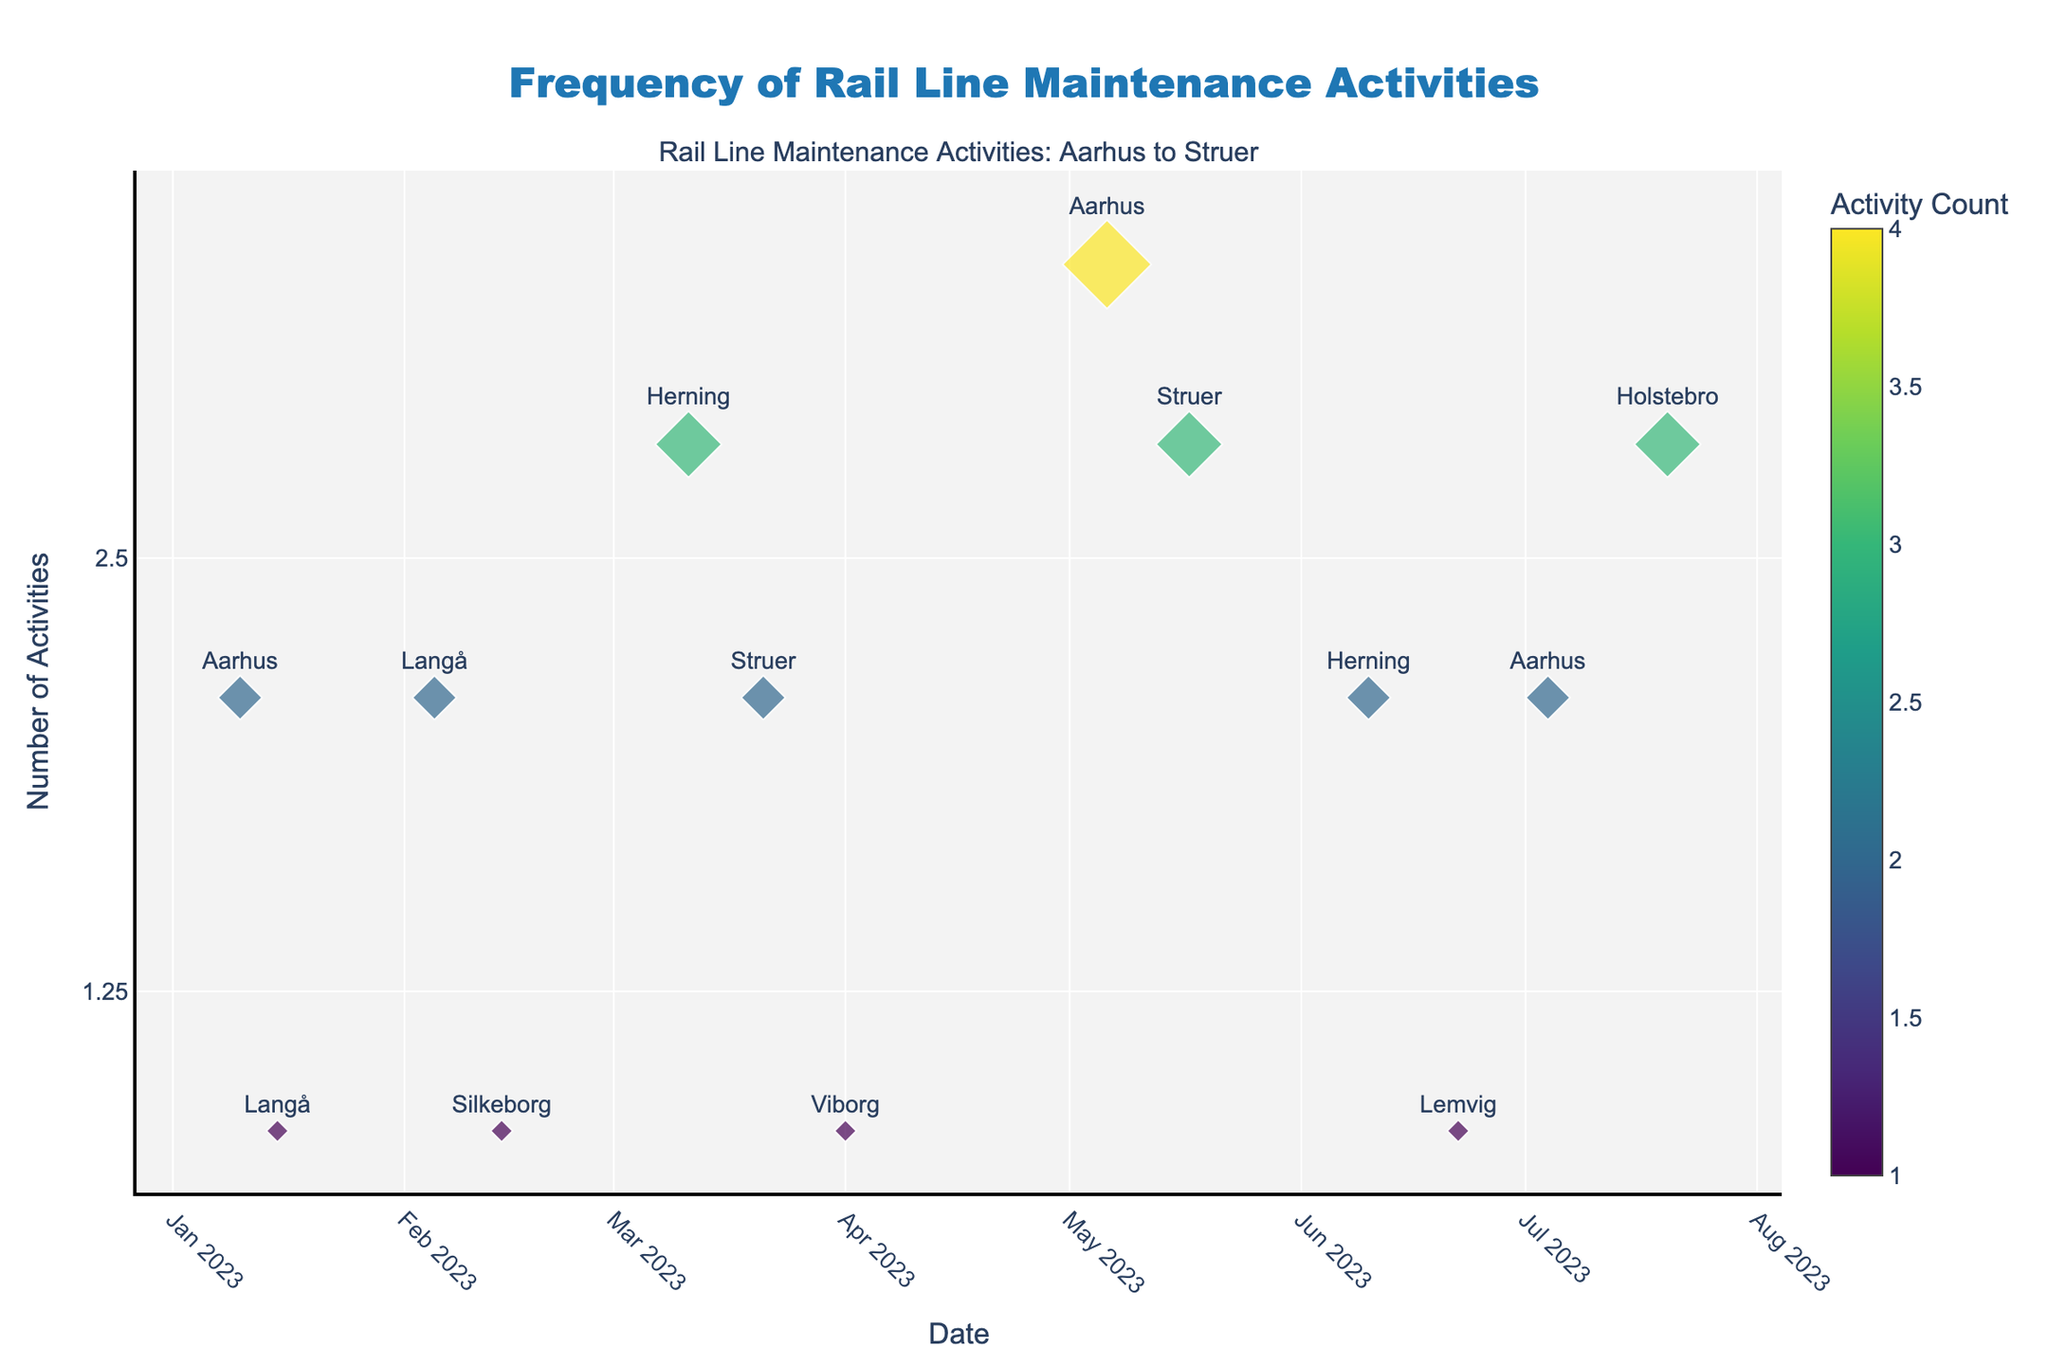What is the title of the plot? The title is usually found at the top of the plot. In this case, it reads "Frequency of Rail Line Maintenance Activities".
Answer: Frequency of Rail Line Maintenance Activities How many maintenance activities were recorded in Aarhus in May? Locate the markers labeled "Aarhus" on the plot. There is a point in May, and the Activity Count indicated is 4.
Answer: 4 Which location had the highest number of maintenance activities and how many were there? Look for the largest marker on the plot. The largest marker appears in May for Aarhus with an Activity Count of 4.
Answer: Aarhus, 4 How does the log scale on the y-axis affect the representation of Activity Counts? The log scale compresses the range of high values and expands the range of low values, making it easier to compare Activity Counts that vary widely. For example, the difference between 1 and 2 is shown more prominently, while higher values like 2, 3, and 4 appear closer together.
Answer: Compresses high values, expands low values What is the total number of maintenance activities recorded in Struer over the given period? Identify the markers labeled "Struer" and sum their Activity Counts: 2 (March) + 3 (May) = 5.
Answer: 5 Which date had a maintenance activity count of 3 in Herning? Find the marker corresponding to Herning with an Activity Count of 3. This is seen in March.
Answer: March 11, 2023 What are the distinct locations where maintenance activities were recorded? Look at the text labels on the plot for the different locations. The locations include Aarhus, Langå, Silkeborg, Herning, Struer, Viborg, Lemvig, and Holstebro.
Answer: Aarhus, Langå, Silkeborg, Herning, Struer, Viborg, Lemvig, Holstebro Compare the maintenance activities in March and June in Herning. Which month had more activities? Locate the markers for Herning in March and June. March has an Activity Count of 3, and June has 2. Therefore, March had more activities.
Answer: March What is the color significance of the markers on the plot? The color varies according to the Activity Count, with a colorbar on the right side providing context. The general principle is that different colors represent different counts, with lighter/darker colors indicating higher/lower values, respectively.
Answer: Represents Activity Count How many locations experienced only one maintenance activity? Find markers with a size corresponding to an Activity Count of 1: Langå (Jan, Feb), Silkeborg (Feb), Viborg (Apr), and Lemvig (June). This gives us 4 instances.
Answer: 4 